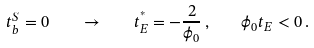<formula> <loc_0><loc_0><loc_500><loc_500>t _ { b } ^ { S } = 0 \quad \rightarrow \quad t ^ { ^ { * } } _ { E } = - \frac { 2 } { \phi _ { 0 } } \, , \quad \phi _ { 0 } t _ { E } < 0 \, .</formula> 